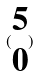<formula> <loc_0><loc_0><loc_500><loc_500>( \begin{matrix} 5 \\ 0 \end{matrix} )</formula> 